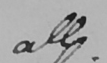What text is written in this handwritten line? all 